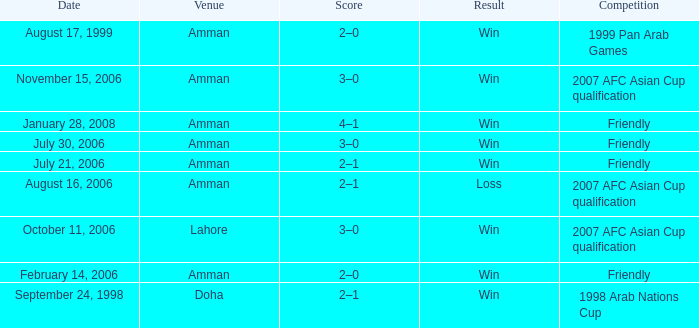Could you help me parse every detail presented in this table? {'header': ['Date', 'Venue', 'Score', 'Result', 'Competition'], 'rows': [['August 17, 1999', 'Amman', '2–0', 'Win', '1999 Pan Arab Games'], ['November 15, 2006', 'Amman', '3–0', 'Win', '2007 AFC Asian Cup qualification'], ['January 28, 2008', 'Amman', '4–1', 'Win', 'Friendly'], ['July 30, 2006', 'Amman', '3–0', 'Win', 'Friendly'], ['July 21, 2006', 'Amman', '2–1', 'Win', 'Friendly'], ['August 16, 2006', 'Amman', '2–1', 'Loss', '2007 AFC Asian Cup qualification'], ['October 11, 2006', 'Lahore', '3–0', 'Win', '2007 AFC Asian Cup qualification'], ['February 14, 2006', 'Amman', '2–0', 'Win', 'Friendly'], ['September 24, 1998', 'Doha', '2–1', 'Win', '1998 Arab Nations Cup']]} Where did Ra'fat Ali play on August 17, 1999? Amman. 